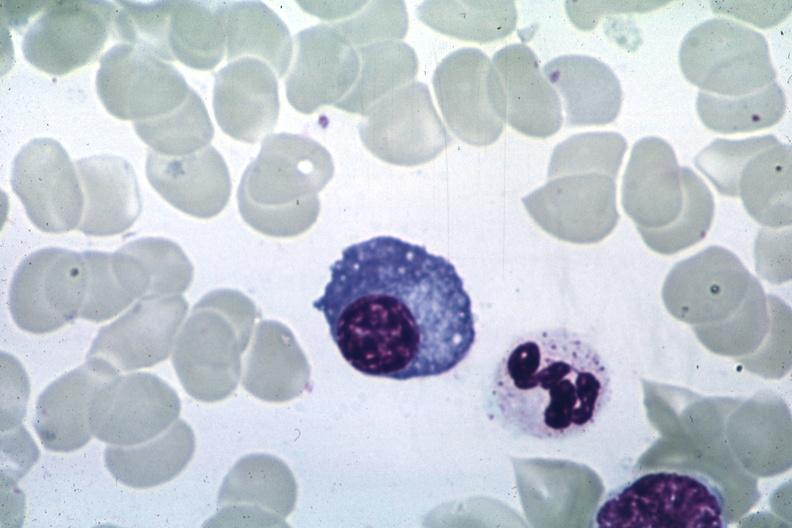what does this image show?
Answer the question using a single word or phrase. Wrights 